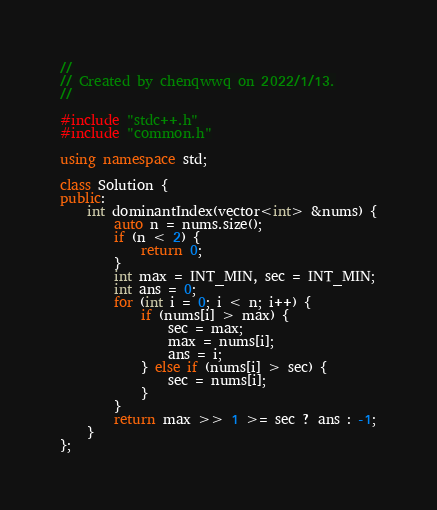<code> <loc_0><loc_0><loc_500><loc_500><_C++_>//
// Created by chenqwwq on 2022/1/13.
//

#include "stdc++.h"
#include "common.h"

using namespace std;

class Solution {
public:
    int dominantIndex(vector<int> &nums) {
        auto n = nums.size();
        if (n < 2) {
            return 0;
        }
        int max = INT_MIN, sec = INT_MIN;
        int ans = 0;
        for (int i = 0; i < n; i++) {
            if (nums[i] > max) {
                sec = max;
                max = nums[i];
                ans = i;
            } else if (nums[i] > sec) {
                sec = nums[i];
            }
        }
        return max >> 1 >= sec ? ans : -1;
    }
};</code> 